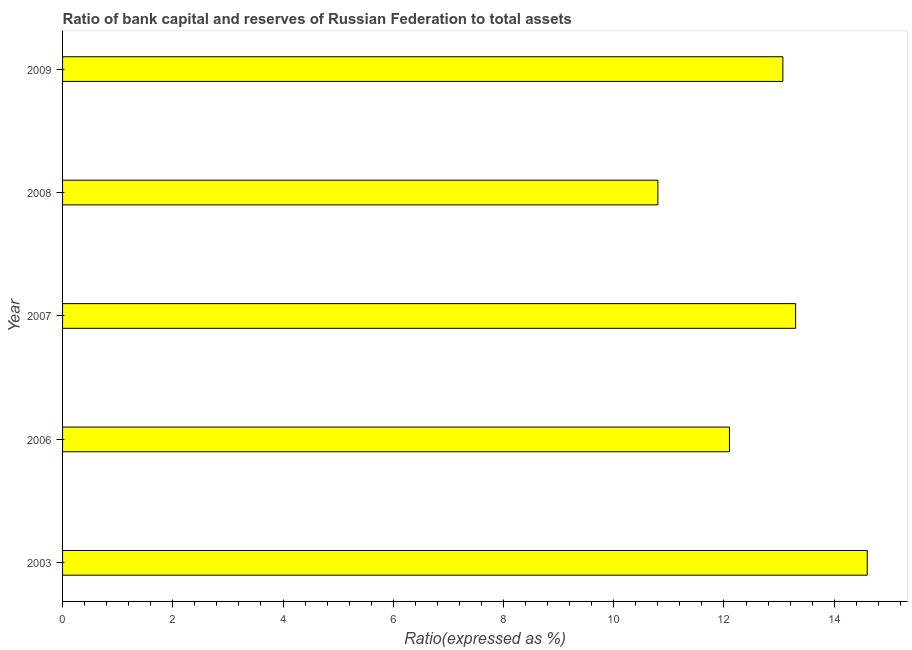Does the graph contain any zero values?
Ensure brevity in your answer.  No. Does the graph contain grids?
Give a very brief answer. No. What is the title of the graph?
Offer a terse response. Ratio of bank capital and reserves of Russian Federation to total assets. What is the label or title of the X-axis?
Your answer should be compact. Ratio(expressed as %). What is the label or title of the Y-axis?
Provide a succinct answer. Year. What is the bank capital to assets ratio in 2009?
Your answer should be very brief. 13.07. Across all years, what is the maximum bank capital to assets ratio?
Your answer should be compact. 14.6. Across all years, what is the minimum bank capital to assets ratio?
Provide a succinct answer. 10.8. In which year was the bank capital to assets ratio minimum?
Provide a succinct answer. 2008. What is the sum of the bank capital to assets ratio?
Your answer should be very brief. 63.87. What is the difference between the bank capital to assets ratio in 2006 and 2009?
Your answer should be very brief. -0.97. What is the average bank capital to assets ratio per year?
Offer a terse response. 12.77. What is the median bank capital to assets ratio?
Offer a terse response. 13.07. In how many years, is the bank capital to assets ratio greater than 6.8 %?
Make the answer very short. 5. Do a majority of the years between 2003 and 2008 (inclusive) have bank capital to assets ratio greater than 13.6 %?
Keep it short and to the point. No. What is the ratio of the bank capital to assets ratio in 2003 to that in 2008?
Your answer should be compact. 1.35. Is the bank capital to assets ratio in 2006 less than that in 2007?
Your response must be concise. Yes. What is the difference between the highest and the lowest bank capital to assets ratio?
Offer a terse response. 3.8. How many bars are there?
Provide a succinct answer. 5. Are all the bars in the graph horizontal?
Offer a very short reply. Yes. What is the difference between two consecutive major ticks on the X-axis?
Make the answer very short. 2. What is the Ratio(expressed as %) of 2006?
Your response must be concise. 12.1. What is the Ratio(expressed as %) of 2008?
Give a very brief answer. 10.8. What is the Ratio(expressed as %) in 2009?
Your answer should be very brief. 13.07. What is the difference between the Ratio(expressed as %) in 2003 and 2008?
Offer a very short reply. 3.8. What is the difference between the Ratio(expressed as %) in 2003 and 2009?
Offer a terse response. 1.53. What is the difference between the Ratio(expressed as %) in 2006 and 2008?
Offer a very short reply. 1.3. What is the difference between the Ratio(expressed as %) in 2006 and 2009?
Offer a very short reply. -0.97. What is the difference between the Ratio(expressed as %) in 2007 and 2008?
Your response must be concise. 2.5. What is the difference between the Ratio(expressed as %) in 2007 and 2009?
Offer a very short reply. 0.23. What is the difference between the Ratio(expressed as %) in 2008 and 2009?
Provide a succinct answer. -2.27. What is the ratio of the Ratio(expressed as %) in 2003 to that in 2006?
Ensure brevity in your answer.  1.21. What is the ratio of the Ratio(expressed as %) in 2003 to that in 2007?
Give a very brief answer. 1.1. What is the ratio of the Ratio(expressed as %) in 2003 to that in 2008?
Your response must be concise. 1.35. What is the ratio of the Ratio(expressed as %) in 2003 to that in 2009?
Provide a succinct answer. 1.12. What is the ratio of the Ratio(expressed as %) in 2006 to that in 2007?
Your answer should be compact. 0.91. What is the ratio of the Ratio(expressed as %) in 2006 to that in 2008?
Your answer should be compact. 1.12. What is the ratio of the Ratio(expressed as %) in 2006 to that in 2009?
Provide a succinct answer. 0.93. What is the ratio of the Ratio(expressed as %) in 2007 to that in 2008?
Provide a short and direct response. 1.23. What is the ratio of the Ratio(expressed as %) in 2007 to that in 2009?
Your answer should be compact. 1.02. What is the ratio of the Ratio(expressed as %) in 2008 to that in 2009?
Offer a terse response. 0.83. 